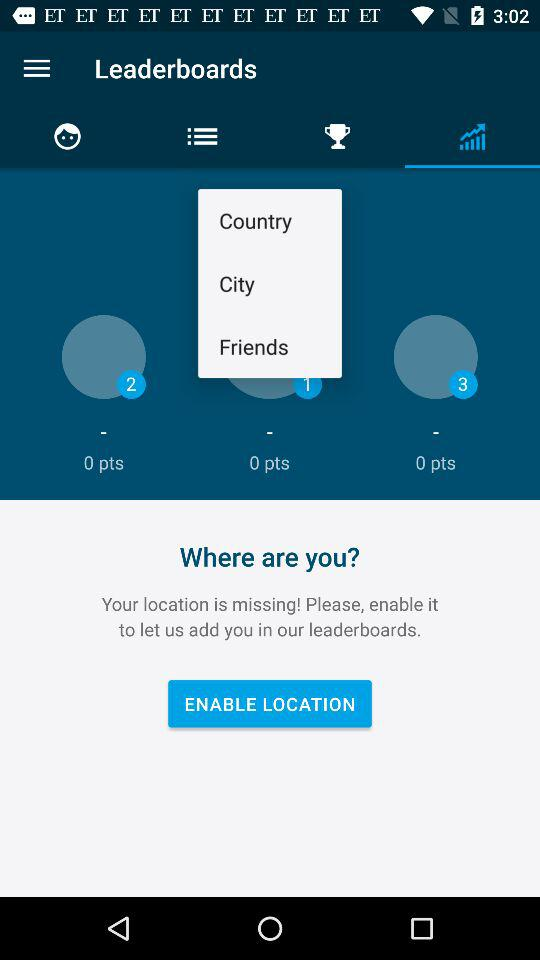How many points do I have in the leaderboard?
Answer the question using a single word or phrase. 0 